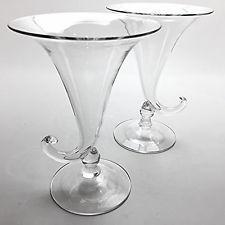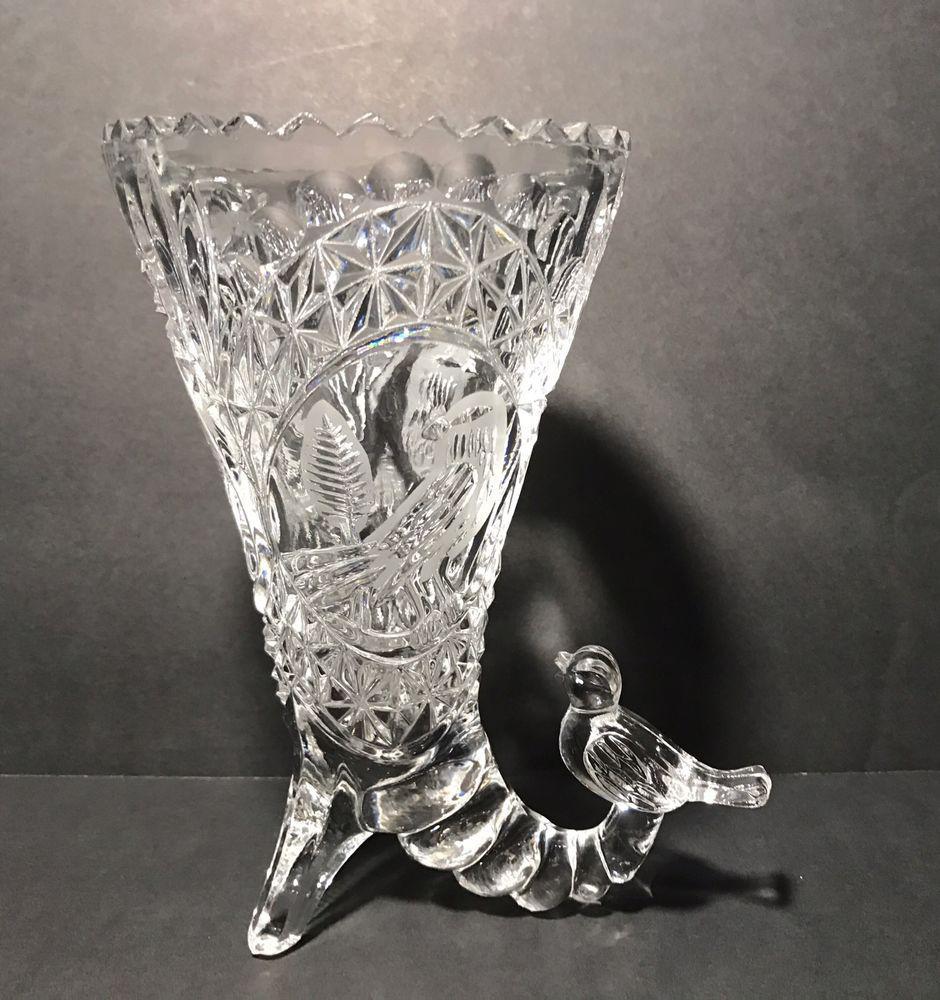The first image is the image on the left, the second image is the image on the right. Given the left and right images, does the statement "The left and right image contains the same number of glass horn vases." hold true? Answer yes or no. No. The first image is the image on the left, the second image is the image on the right. Given the left and right images, does the statement "There is exactly one curved glass vase is shown in every photograph and in every photo the entire vase is visible." hold true? Answer yes or no. No. 